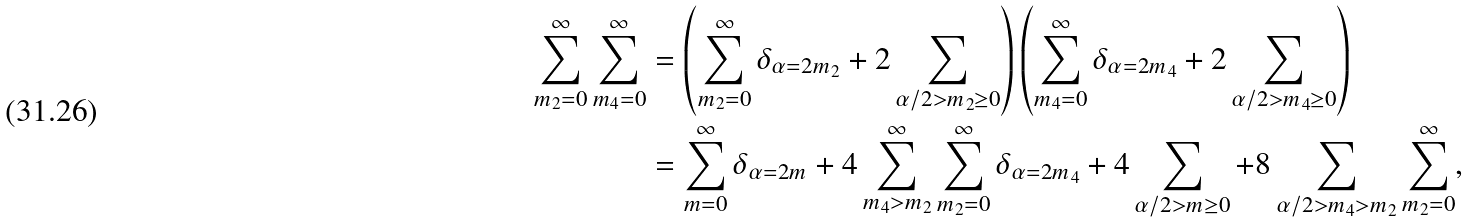Convert formula to latex. <formula><loc_0><loc_0><loc_500><loc_500>\sum _ { m _ { 2 } = 0 } ^ { \infty } \sum _ { m _ { 4 } = 0 } ^ { \infty } & = \left ( \sum _ { m _ { 2 } = 0 } ^ { \infty } \delta _ { \alpha = 2 m _ { 2 } } + 2 \sum _ { \alpha / 2 > m _ { 2 } \geq 0 } \right ) \left ( \sum _ { m _ { 4 } = 0 } ^ { \infty } \delta _ { \alpha = 2 m _ { 4 } } + 2 \sum _ { \alpha / 2 > m _ { 4 } \geq 0 } \right ) \\ & = \sum _ { m = 0 } ^ { \infty } \delta _ { \alpha = 2 m } + 4 \sum _ { m _ { 4 } > m _ { 2 } } ^ { \infty } \sum _ { m _ { 2 } = 0 } ^ { \infty } \delta _ { \alpha = 2 m _ { 4 } } + 4 \sum _ { \alpha / 2 > m \geq 0 } + 8 \sum _ { \alpha / 2 > m _ { 4 } > m _ { 2 } } \sum _ { m _ { 2 } = 0 } ^ { \infty } ,</formula> 